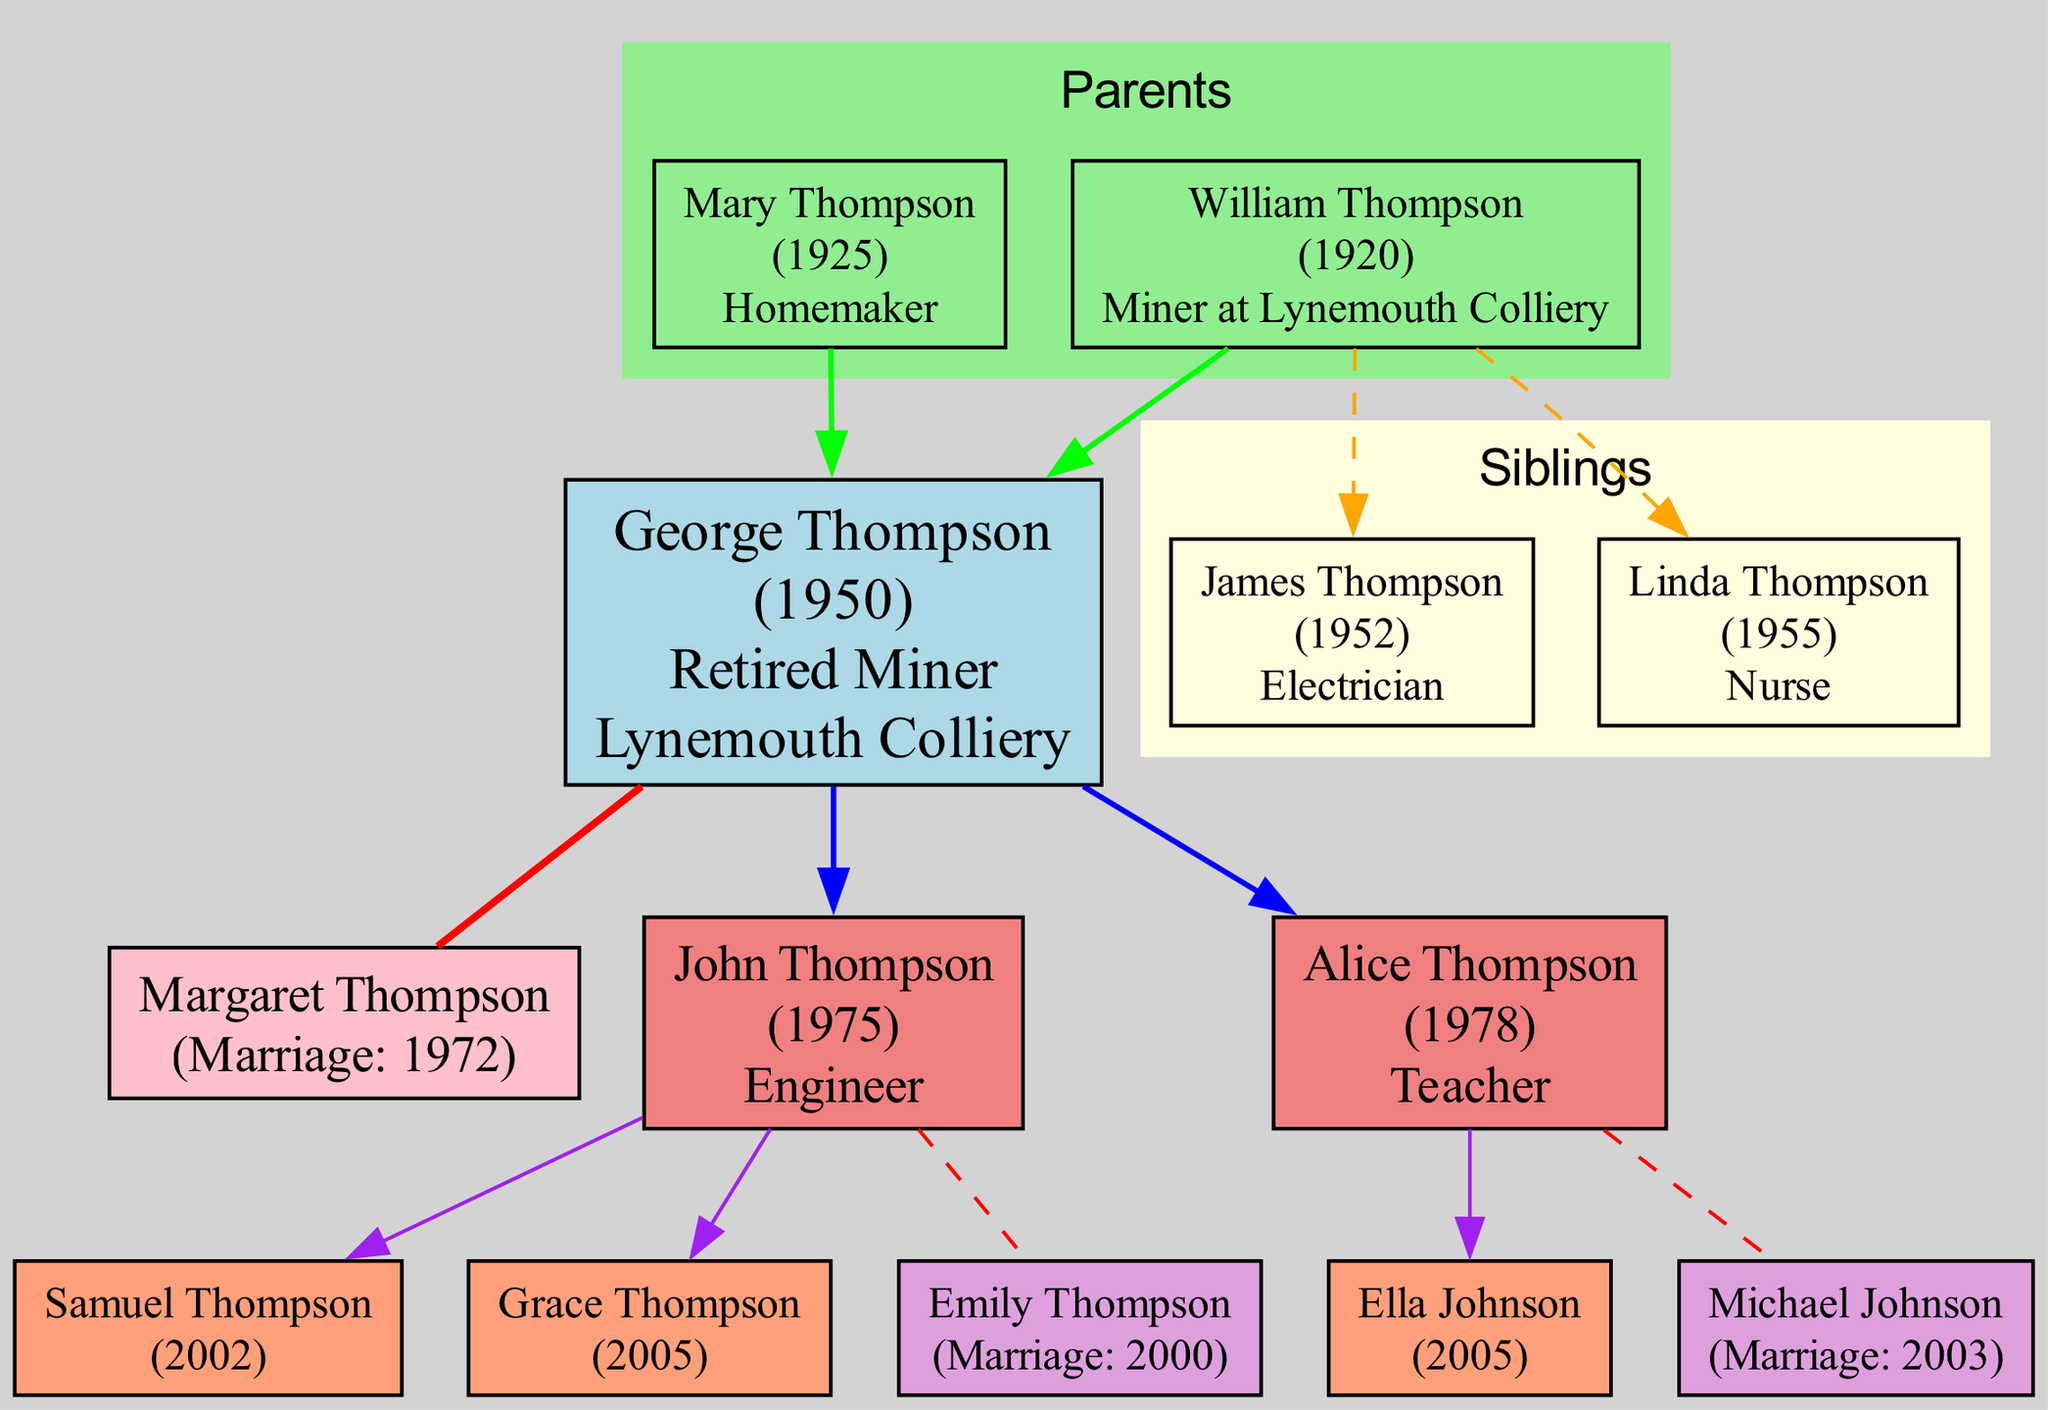What is the occupation of George Thompson? The diagram indicates that George Thompson's occupation is listed directly in his node, which shows "Retired Miner."
Answer: Retired Miner How many children does George Thompson have? By counting the children nodes connected to George Thompson's node, we see two children: John Thompson and Alice Thompson.
Answer: 2 What year did John Thompson get married? John Thompson’s spouse's node includes the marriage year, which is 2000 as indicated in the diagram.
Answer: 2000 Who is Alice Thompson's spouse? The node connected to Alice Thompson lists her spouse's name, which is “Michael Johnson.”
Answer: Michael Johnson What is the birth year of Grace Thompson? The node representing Grace Thompson shows her birth year, which is 2005, as stated in the child nodes.
Answer: 2005 How many generations are represented in the diagram? The diagram includes George Thompson, his parents, and his children. This represents three generations, since it displays George's parents, himself, and his children.
Answer: 3 What occupation does Mary Thompson have? Mary Thompson's node in the parents' section includes her occupation, which is indicated as "Homemaker."
Answer: Homemaker Which child of George Thompson is an Engineer? By looking at the nodes representing George Thompson's children, it can be seen that John Thompson's occupation is mentioned as "Engineer."
Answer: John Thompson How many grandchildren does George Thompson have? By counting the grandchildren nodes under the children nodes (Samuel and Grace under John, and Ella under Alice), there are three grandchildren shown.
Answer: 3 